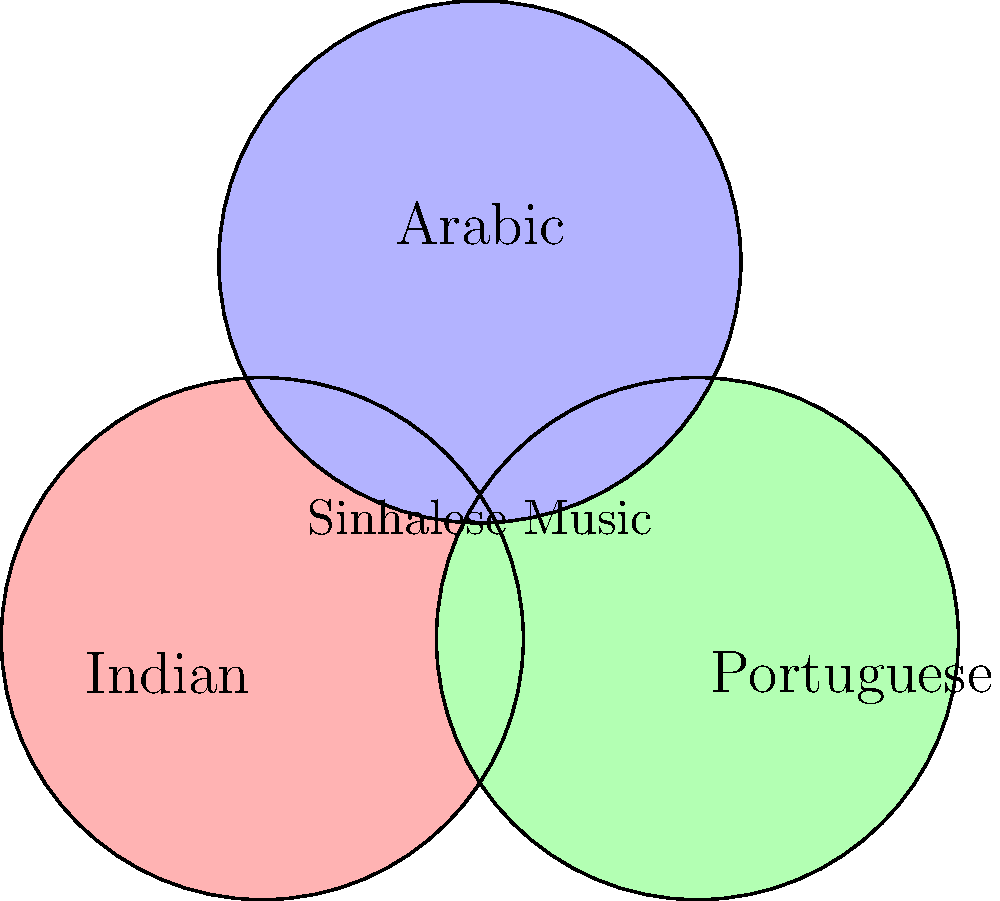In the Venn diagram above, which cultural influence is represented by the region where all three circles overlap, indicating the most significant combined impact on Sinhalese music? To answer this question, we need to analyze the Venn diagram and understand the cultural influences on Sinhalese music:

1. The diagram shows three overlapping circles representing different cultural influences: Indian, Portuguese, and Arabic.

2. Each circle represents the individual influence of that culture on Sinhalese music.

3. The areas where circles overlap indicate shared influences between cultures.

4. The central region, where all three circles intersect, represents the area where Indian, Portuguese, and Arabic influences combine.

5. This central region is labeled "Sinhalese Music," indicating that it is the core of Sinhalese musical tradition.

6. The question asks about the most significant combined impact, which would be represented by this central area where all three cultural influences merge.

Therefore, the region where all three circles overlap represents the combination of Indian, Portuguese, and Arabic influences, which together form the core of Sinhalese music.
Answer: Indian, Portuguese, and Arabic 